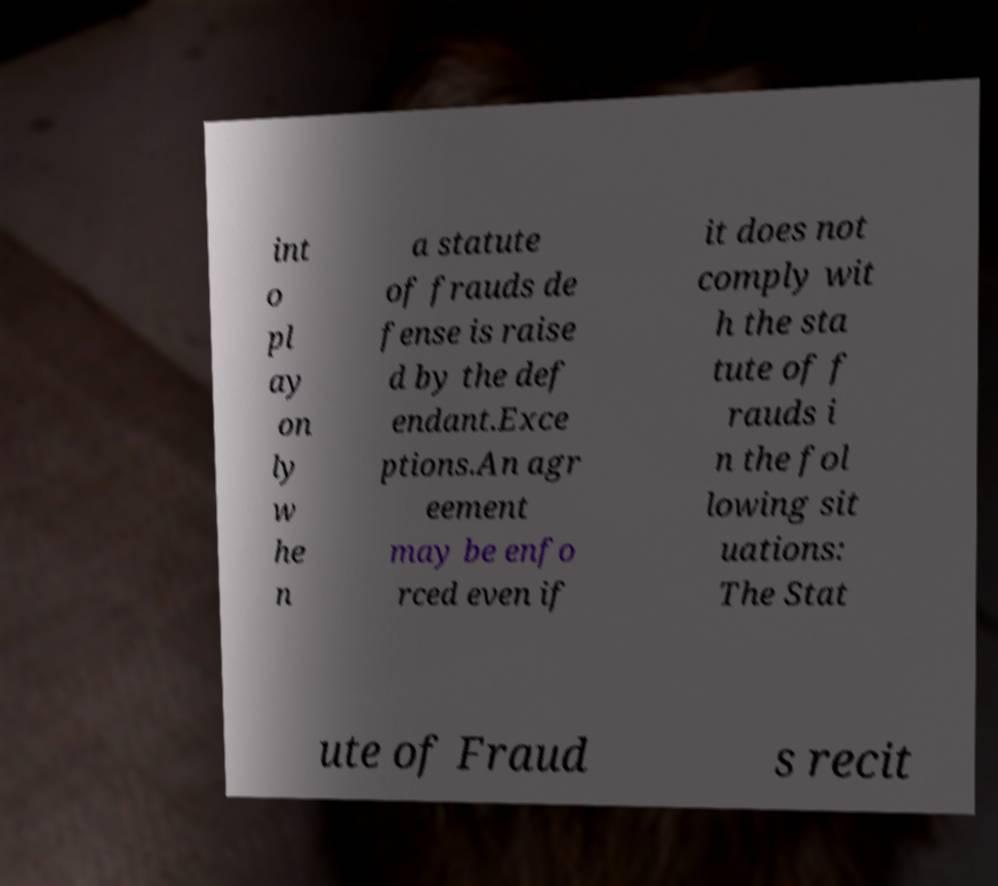What messages or text are displayed in this image? I need them in a readable, typed format. int o pl ay on ly w he n a statute of frauds de fense is raise d by the def endant.Exce ptions.An agr eement may be enfo rced even if it does not comply wit h the sta tute of f rauds i n the fol lowing sit uations: The Stat ute of Fraud s recit 